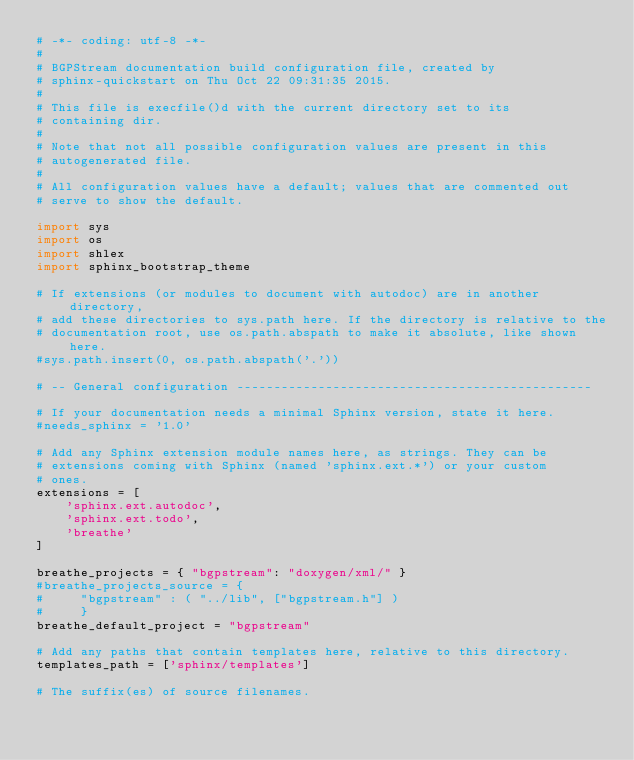<code> <loc_0><loc_0><loc_500><loc_500><_Python_># -*- coding: utf-8 -*-
#
# BGPStream documentation build configuration file, created by
# sphinx-quickstart on Thu Oct 22 09:31:35 2015.
#
# This file is execfile()d with the current directory set to its
# containing dir.
#
# Note that not all possible configuration values are present in this
# autogenerated file.
#
# All configuration values have a default; values that are commented out
# serve to show the default.

import sys
import os
import shlex
import sphinx_bootstrap_theme

# If extensions (or modules to document with autodoc) are in another directory,
# add these directories to sys.path here. If the directory is relative to the
# documentation root, use os.path.abspath to make it absolute, like shown here.
#sys.path.insert(0, os.path.abspath('.'))

# -- General configuration ------------------------------------------------

# If your documentation needs a minimal Sphinx version, state it here.
#needs_sphinx = '1.0'

# Add any Sphinx extension module names here, as strings. They can be
# extensions coming with Sphinx (named 'sphinx.ext.*') or your custom
# ones.
extensions = [
    'sphinx.ext.autodoc',
    'sphinx.ext.todo',
    'breathe'
]

breathe_projects = { "bgpstream": "doxygen/xml/" }
#breathe_projects_source = {
#     "bgpstream" : ( "../lib", ["bgpstream.h"] )
#     }
breathe_default_project = "bgpstream"

# Add any paths that contain templates here, relative to this directory.
templates_path = ['sphinx/templates']

# The suffix(es) of source filenames.</code> 